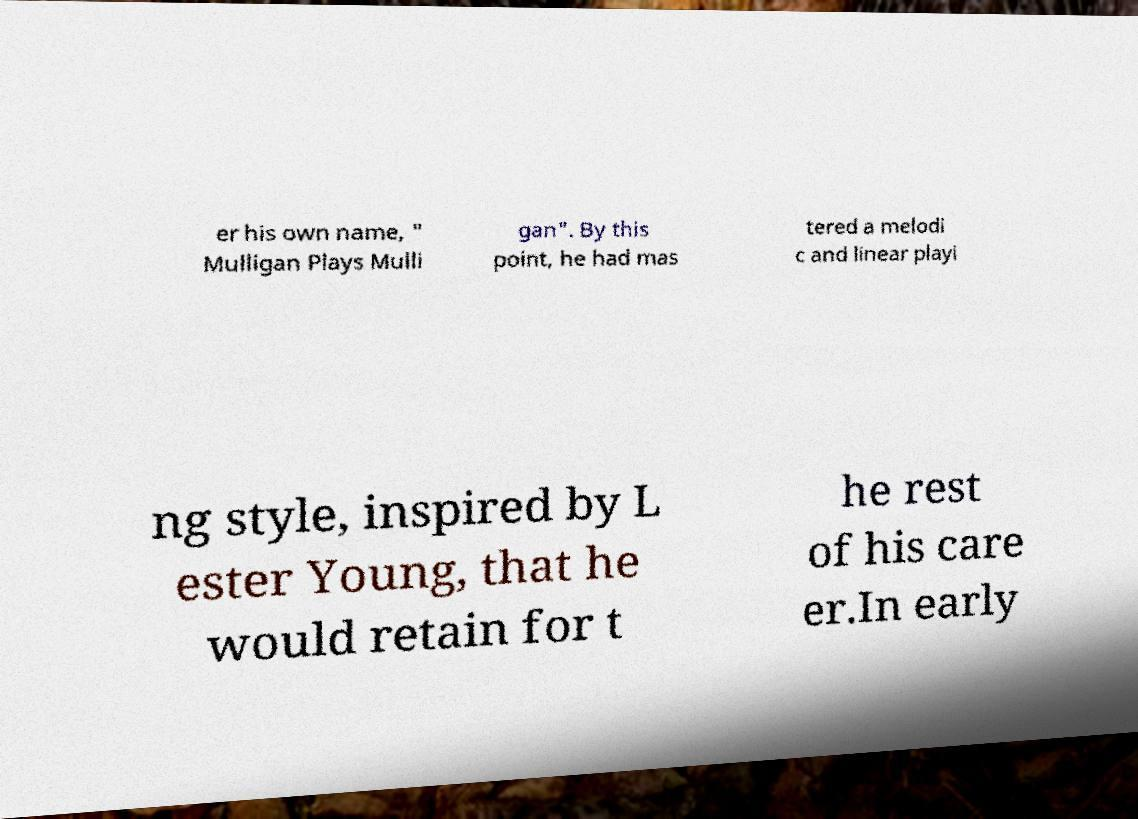For documentation purposes, I need the text within this image transcribed. Could you provide that? er his own name, " Mulligan Plays Mulli gan". By this point, he had mas tered a melodi c and linear playi ng style, inspired by L ester Young, that he would retain for t he rest of his care er.In early 